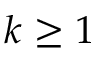<formula> <loc_0><loc_0><loc_500><loc_500>k \geq 1</formula> 